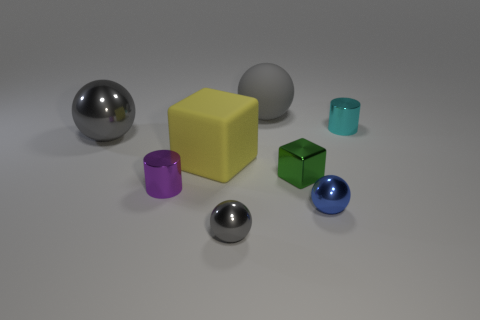There is a cube that is to the left of the big sphere that is right of the gray shiny sphere that is on the left side of the purple cylinder; what is its material?
Offer a very short reply. Rubber. What is the large cube made of?
Provide a short and direct response. Rubber. Do the large matte object in front of the big gray shiny ball and the small metal cylinder that is to the left of the cyan metal cylinder have the same color?
Offer a very short reply. No. Is the number of yellow rubber things greater than the number of big red things?
Offer a very short reply. Yes. What number of tiny shiny spheres are the same color as the matte cube?
Ensure brevity in your answer.  0. There is a rubber thing that is the same shape as the tiny green metal object; what color is it?
Give a very brief answer. Yellow. There is a object that is behind the purple shiny object and left of the large yellow block; what material is it?
Ensure brevity in your answer.  Metal. Are the large gray ball that is in front of the cyan object and the tiny purple cylinder that is behind the small gray metallic object made of the same material?
Ensure brevity in your answer.  Yes. How big is the purple cylinder?
Make the answer very short. Small. The green object that is the same shape as the yellow matte thing is what size?
Offer a very short reply. Small. 